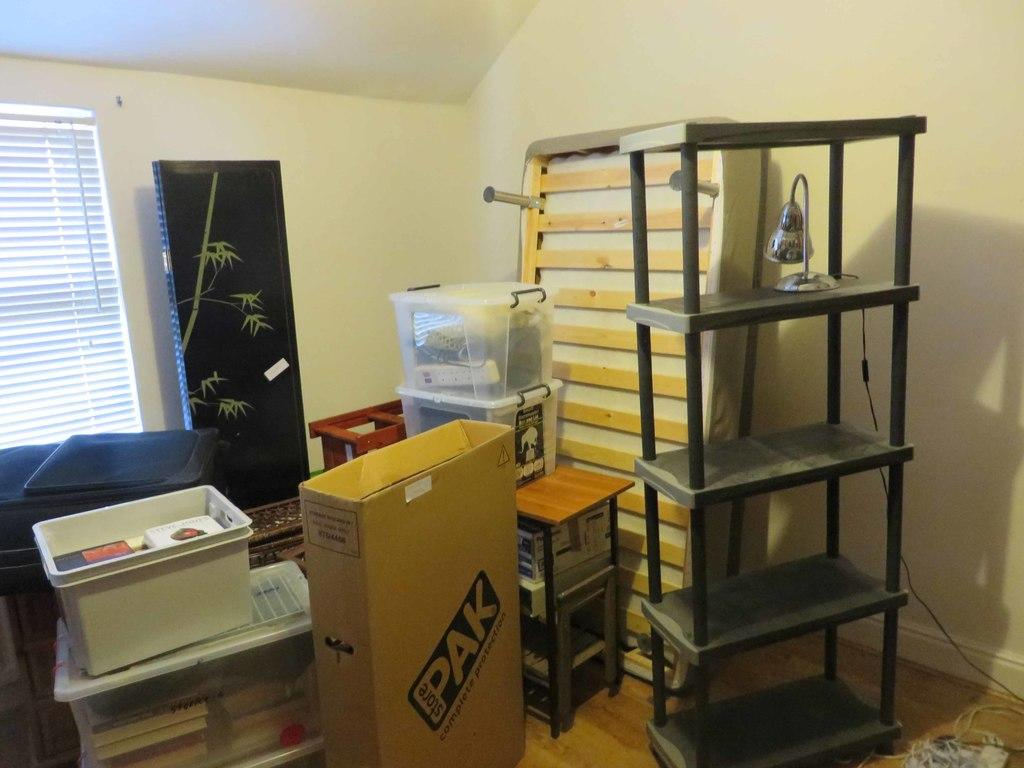Provide a one-sentence caption for the provided image. A room that looks packed for a moved with a box that has the label Pak. 